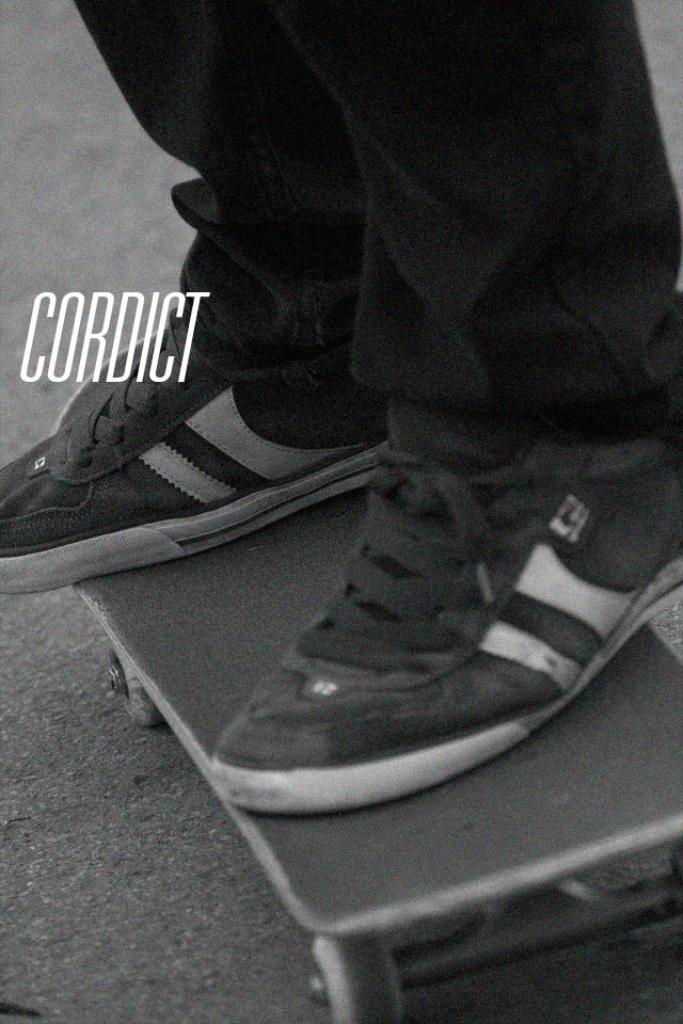What is the main subject of the image? There is a person in the image. What is the person doing in the image? The person is standing on a roller skateboard. What is the color scheme of the image? The image is in black and white color. Is there any text or wording in the image? Yes, the word "CORDICT" is written on the image. Can you see any frogs or fairies in the image? No, there are no frogs or fairies present in the image. What is the person doing at the edge of the image? The person is not at the edge of the image; they are standing on a roller skateboard in the center of the image. 